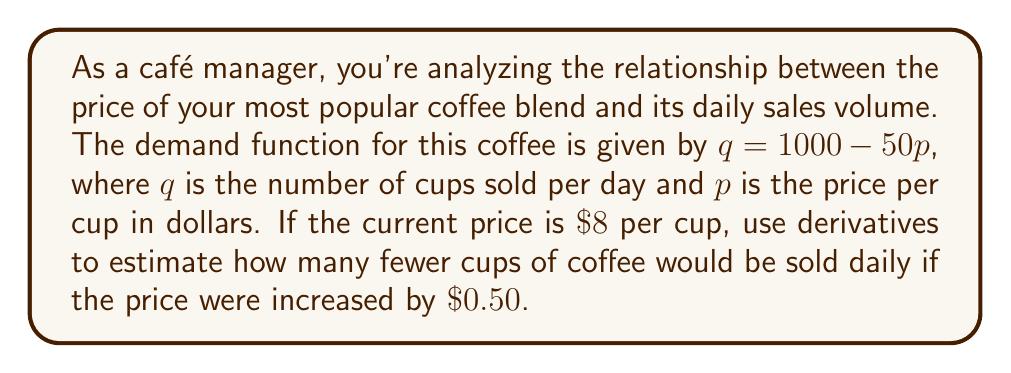Teach me how to tackle this problem. To solve this problem, we'll use the concept of derivatives to estimate the change in quantity based on a small change in price. Here's the step-by-step approach:

1) First, let's find the derivative of the demand function with respect to price:
   
   $q = 1000 - 50p$
   $\frac{dq}{dp} = -50$

2) The derivative tells us the rate of change of quantity with respect to price. In this case, it's constant: for every $\$1$ increase in price, we expect a decrease of 50 cups sold.

3) We're interested in a $\$0.50$ price increase. We can estimate the change in quantity using the derivative:

   $\Delta q \approx \frac{dq}{dp} \cdot \Delta p$
   $\Delta q \approx -50 \cdot 0.50 = -25$

4) The negative sign indicates a decrease in quantity sold.

Therefore, we estimate that increasing the price by $\$0.50$ would result in approximately 25 fewer cups of coffee sold daily.

Note: This is an estimate based on the linear approximation provided by the derivative. For small changes in price, this estimate is usually quite accurate. For larger price changes, the actual change might differ somewhat from this estimate.
Answer: Approximately 25 fewer cups of coffee would be sold daily. 